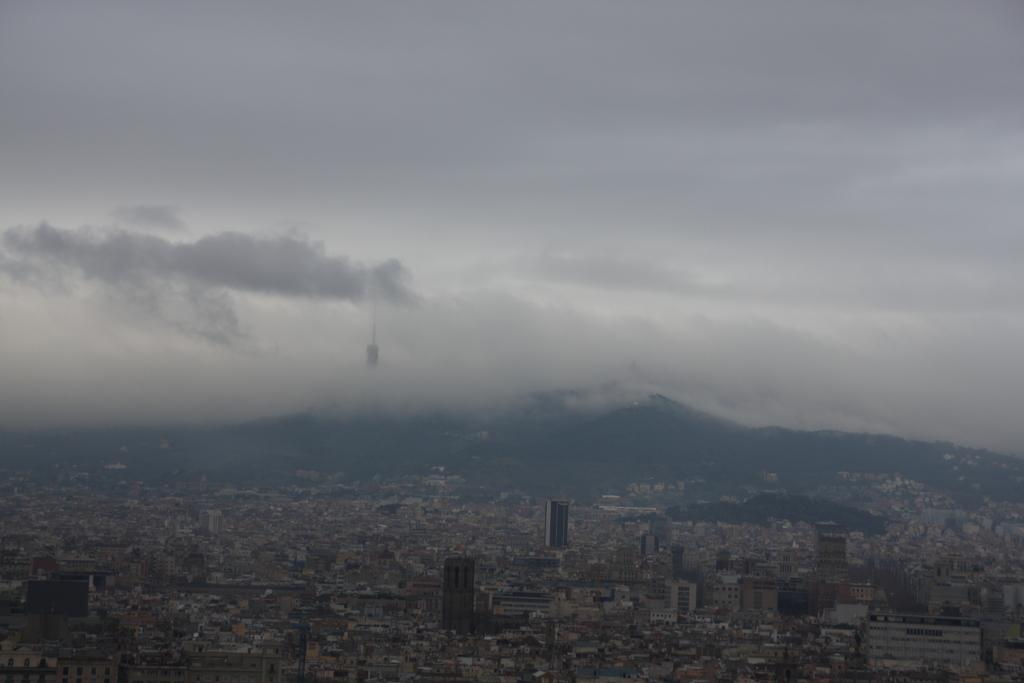From where was the image taken? The image is taken from a high vantage point. What is the main subject of the image? The image shows a city. What structures can be seen in the image? There are buildings in the image. What natural feature is visible in the image? There is a mountain visible in the image. What else can be seen in the sky in the image? There are clouds in the image. How does the city taste in the image? The city does not have a taste, as it is a visual representation in the image. 